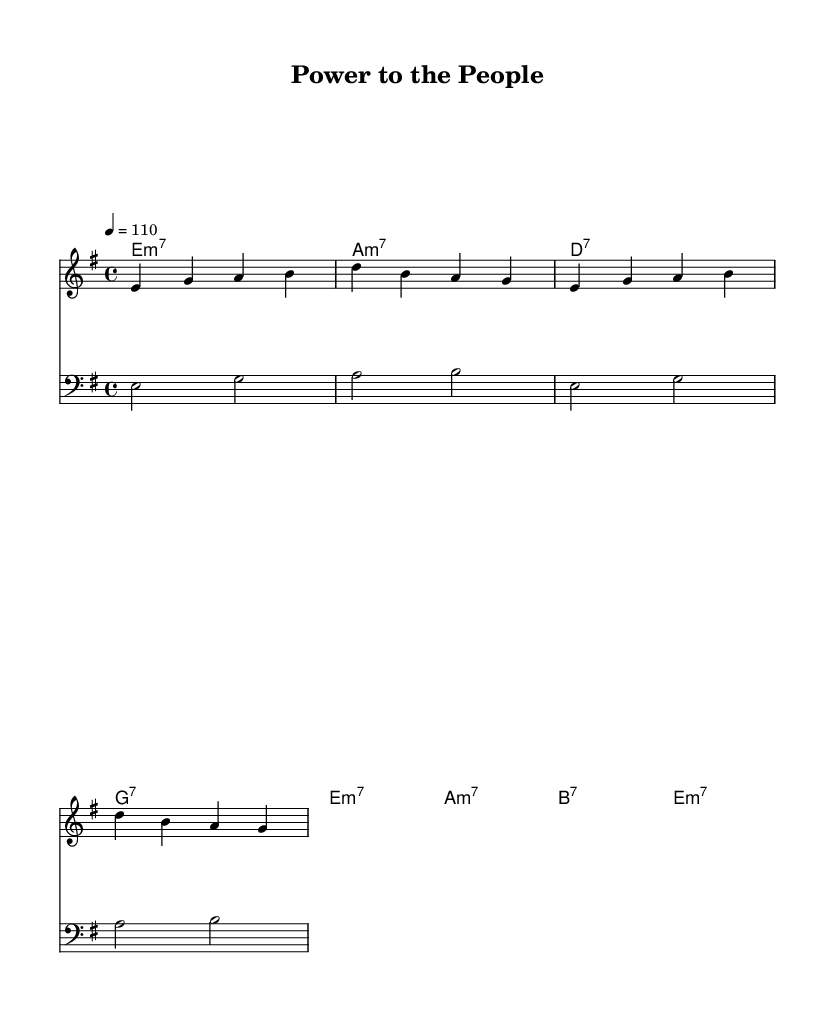What is the key signature of this music? The key signature is E minor, indicated by the presence of one sharp (F#). You can identify the key signature at the beginning of the sheet music, which is a common practice in notation.
Answer: E minor What is the time signature of this music? The time signature is 4/4, shown at the beginning of the score. This indicates that there are four beats in each measure, making it a standard time signature for many musical styles.
Answer: 4/4 What is the tempo marking for this piece? The tempo marking is 110 beats per minute, as indicated by the tempo instruction above the staff. This tells the musician how fast the piece should be played.
Answer: 110 Which chord is played on the first bar of the melody? The chord played in the first bar of the melody is E minor 7. This is deduced from the chord symbols listed directly above the note staff for the melody.
Answer: E minor 7 How many different chords are used in total in this piece? There are seven different chords in total, which can be counted from the chord symbols in the chordNames section. Each unique chord is listed, and duplicates are not repeated.
Answer: Seven What is the significance of the lyrics in the chorus? The lyrics in the chorus emphasize empowerment and social change, a common theme in funk music from the 70s. This reflects the message of community empowerment. The wording "Power to the people" specifically conveys a call to action.
Answer: Empowerment What musical genre does this piece represent? This piece represents the Funk genre, recognized by its rhythmic groove and emphasis on social themes, particularly during the 1970s which was a significant era for funk music in relation to social justice.
Answer: Funk 